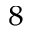<formula> <loc_0><loc_0><loc_500><loc_500>_ { 8 }</formula> 